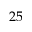Convert formula to latex. <formula><loc_0><loc_0><loc_500><loc_500>2 5</formula> 